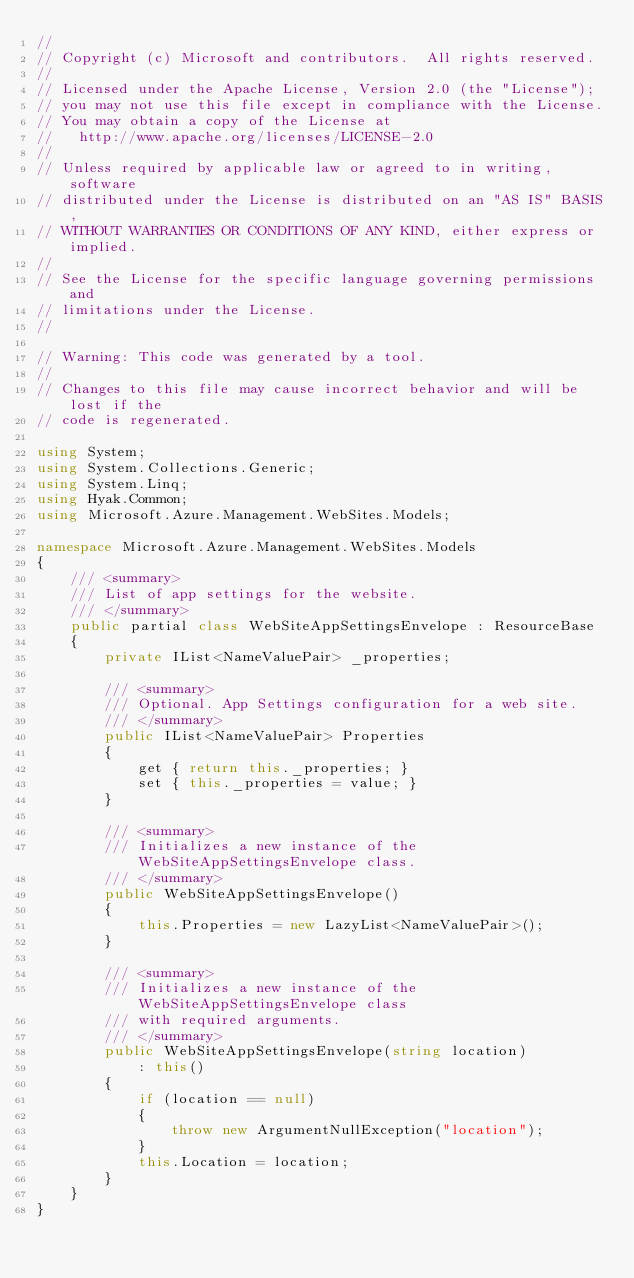<code> <loc_0><loc_0><loc_500><loc_500><_C#_>// 
// Copyright (c) Microsoft and contributors.  All rights reserved.
// 
// Licensed under the Apache License, Version 2.0 (the "License");
// you may not use this file except in compliance with the License.
// You may obtain a copy of the License at
//   http://www.apache.org/licenses/LICENSE-2.0
// 
// Unless required by applicable law or agreed to in writing, software
// distributed under the License is distributed on an "AS IS" BASIS,
// WITHOUT WARRANTIES OR CONDITIONS OF ANY KIND, either express or implied.
// 
// See the License for the specific language governing permissions and
// limitations under the License.
// 

// Warning: This code was generated by a tool.
// 
// Changes to this file may cause incorrect behavior and will be lost if the
// code is regenerated.

using System;
using System.Collections.Generic;
using System.Linq;
using Hyak.Common;
using Microsoft.Azure.Management.WebSites.Models;

namespace Microsoft.Azure.Management.WebSites.Models
{
    /// <summary>
    /// List of app settings for the website.
    /// </summary>
    public partial class WebSiteAppSettingsEnvelope : ResourceBase
    {
        private IList<NameValuePair> _properties;
        
        /// <summary>
        /// Optional. App Settings configuration for a web site.
        /// </summary>
        public IList<NameValuePair> Properties
        {
            get { return this._properties; }
            set { this._properties = value; }
        }
        
        /// <summary>
        /// Initializes a new instance of the WebSiteAppSettingsEnvelope class.
        /// </summary>
        public WebSiteAppSettingsEnvelope()
        {
            this.Properties = new LazyList<NameValuePair>();
        }
        
        /// <summary>
        /// Initializes a new instance of the WebSiteAppSettingsEnvelope class
        /// with required arguments.
        /// </summary>
        public WebSiteAppSettingsEnvelope(string location)
            : this()
        {
            if (location == null)
            {
                throw new ArgumentNullException("location");
            }
            this.Location = location;
        }
    }
}
</code> 